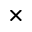<formula> <loc_0><loc_0><loc_500><loc_500>\times</formula> 